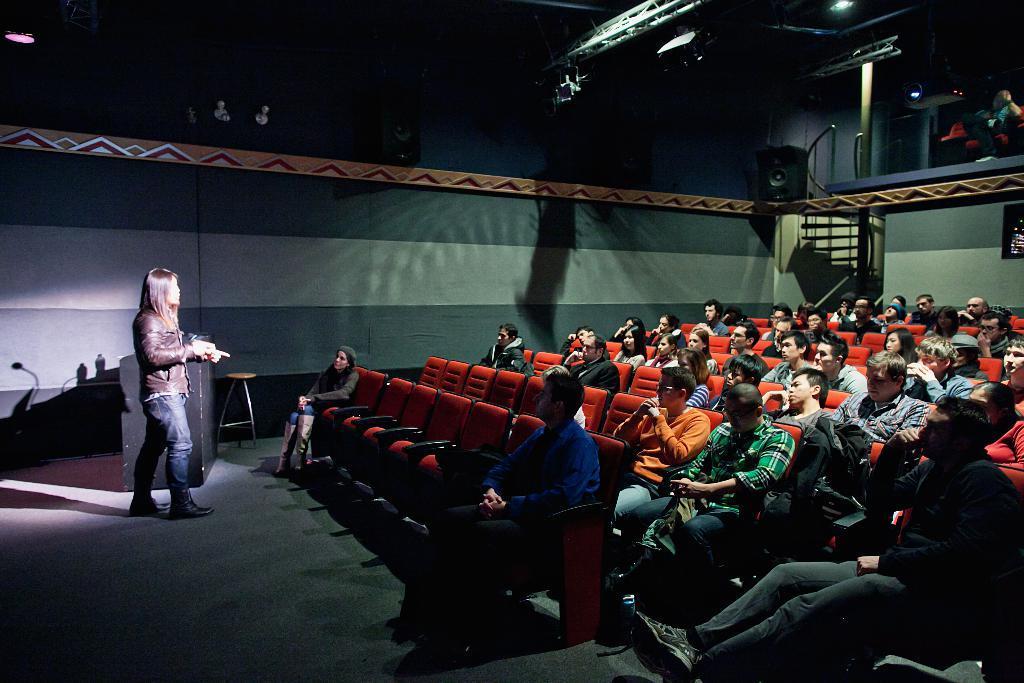Describe this image in one or two sentences. In this picture I can observe a woman standing on the floor on the left side. In front of her I can observe some people sitting on the chairs. There are men and women in this picture. In the background there is a wall. 